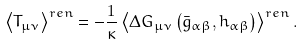Convert formula to latex. <formula><loc_0><loc_0><loc_500><loc_500>\left \langle T _ { \mu \nu } \right \rangle ^ { r e n } = - \frac { 1 } { \kappa } \left \langle \Delta G _ { \mu \nu } \left ( \bar { g } _ { \alpha \beta } , h _ { \alpha \beta } \right ) \right \rangle ^ { r e n } .</formula> 